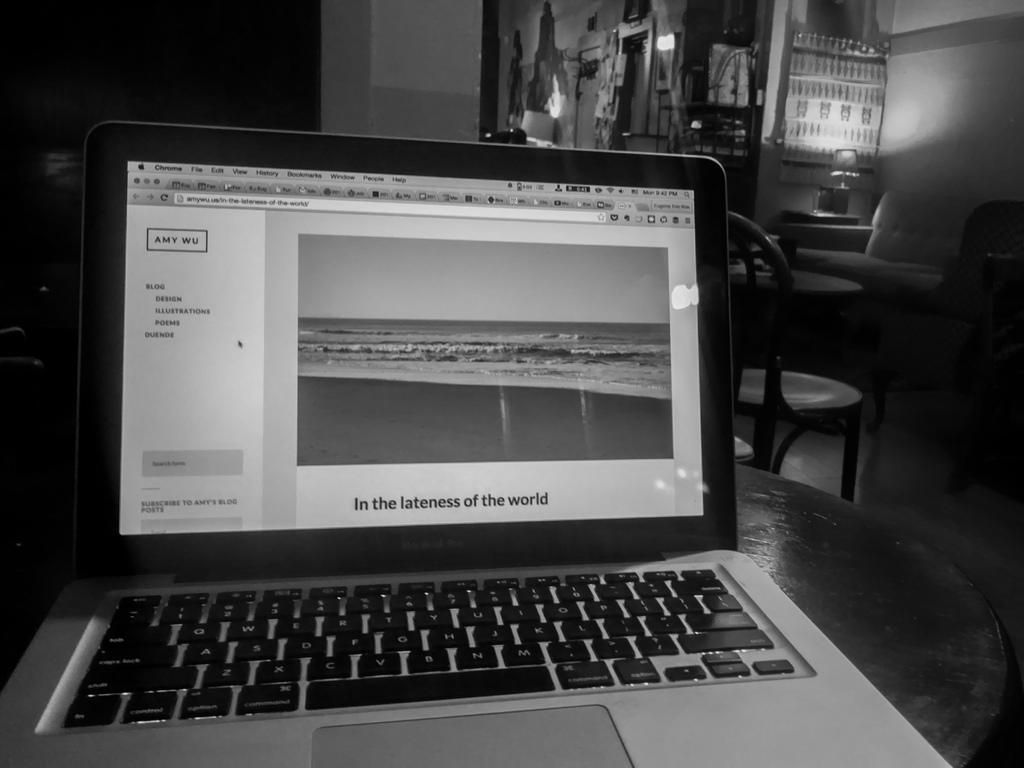What is the caption in the bottom of the screen?
Your answer should be compact. In the lateness of the world. What internet browser is this person using?
Offer a terse response. Chrome. 